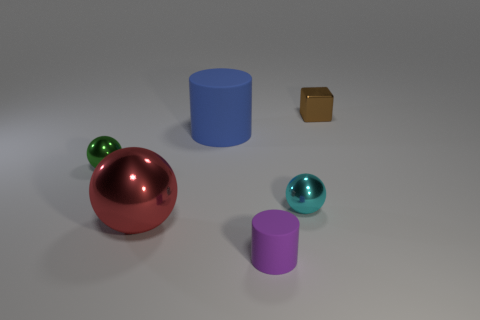Subtract all tiny shiny spheres. How many spheres are left? 1 Add 3 small purple rubber cylinders. How many objects exist? 9 Subtract all cylinders. How many objects are left? 4 Subtract all green things. Subtract all red shiny balls. How many objects are left? 4 Add 3 blue rubber cylinders. How many blue rubber cylinders are left? 4 Add 1 large green metallic balls. How many large green metallic balls exist? 1 Subtract 0 cyan cubes. How many objects are left? 6 